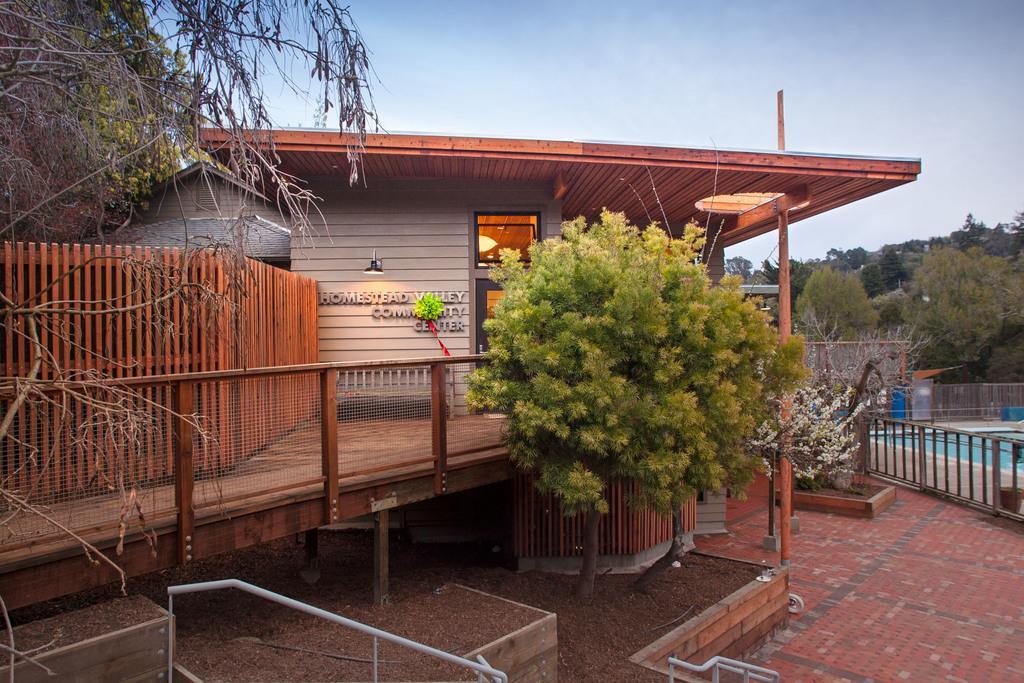Could you give a brief overview of what you see in this image? In this image there is a wooden house. In front of the house there is a tree. There is text on the house. There is a lamp on the wall. There is a fence in front of the house. To the right there is a railing. Behind the railing there is a swimming pool. In the background there are trees. At the top there is the sky. 